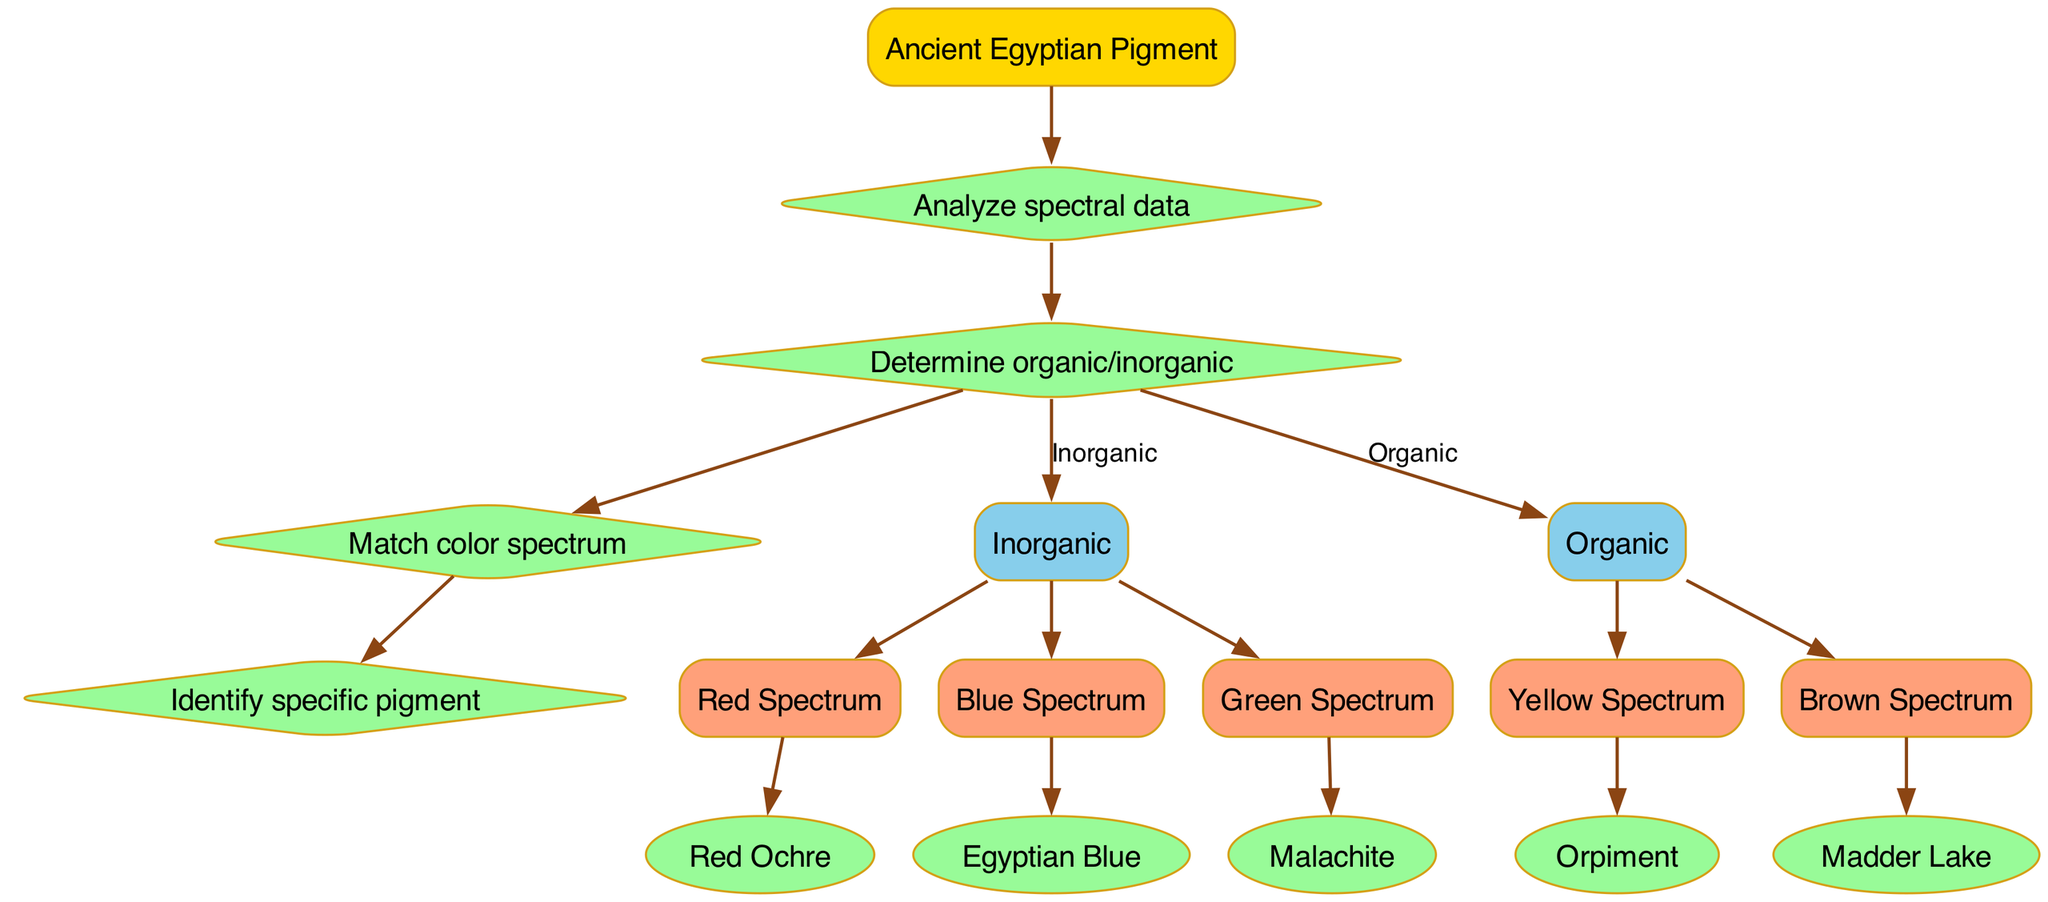What is the root node of the diagram? The root node is labeled as "Ancient Egyptian Pigment," representing the starting point of the classification process.
Answer: Ancient Egyptian Pigment How many decision nodes are present in the diagram? There are four decision nodes that guide the classification process based on spectral data: Analyze spectral data, Determine organic/inorganic, Match color spectrum, and Identify specific pigment.
Answer: 4 Which pigment corresponds to the Blue Spectrum? Following the path from the root to the "Inorganic" branch and then to the "Blue Spectrum," the diagram identifies the pigment as "Egyptian Blue."
Answer: Egyptian Blue What is the first decision made in the classification process? The classification process starts with the decision to "Analyze spectral data," which is the first node after the root.
Answer: Analyze spectral data How are the branches categorized in the diagram? The branches are categorized into two groups: "Inorganic" and "Organic," representing the type of materials for the pigments identified in the classification process.
Answer: Inorganic and Organic Which leaf is associated with the "Yellow Spectrum"? By tracing the path through the "Organic" branch, the "Yellow Spectrum" leads to the leaf labeled "Orpiment," signifying the specific pigment identified.
Answer: Orpiment What is the last decision made in the diagram? The last decision made in the diagram is "Identify specific pigment," which concludes the classification process.
Answer: Identify specific pigment Which spectrum leads to the pigment "Madder Lake"? Following the path down the "Organic" branch to the "Brown Spectrum" node indicates that this path leads to the leaf labeled "Madder Lake."
Answer: Brown Spectrum How many pigments are identified under the "Inorganic" branch? The "Inorganic" branch identifies three pigments: Red Ochre, Egyptian Blue, and Malachite, indicating the variety of inorganic pigments classified.
Answer: 3 